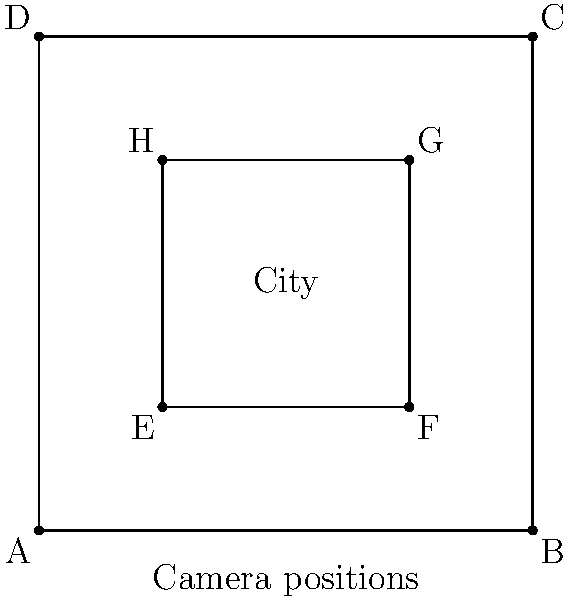As an indie filmmaker, you're planning to capture a cityscape for your documentary on urban life and art. The city can be represented as a rectangle ABCD, and you have four potential camera positions at points E, F, G, and H forming a smaller rectangle inside ABCD. To optimize your shots, you need to determine the maximum number of cameras you can place such that no two cameras can see each other directly (i.e., their line of sight is not obstructed by buildings). How many cameras can you place? To solve this problem, we can use the concept of independent sets in graph theory, applied to the visibility graph of the camera positions. Here's a step-by-step approach:

1. Analyze the visibility between camera positions:
   - E can see F and H directly
   - F can see E and G directly
   - G can see F and H directly
   - H can see E and G directly

2. Create a visibility graph:
   - Each camera position is a node
   - Connect nodes with an edge if they can see each other

3. The resulting graph is a cycle with 4 nodes (E-F-G-H-E)

4. In a cycle graph with 4 nodes, the maximum independent set (set of nodes where no two are adjacent) has 2 nodes

5. This means we can place cameras at 2 positions where they cannot see each other

6. The optimal placements are either:
   - E and G, or
   - F and H

Therefore, the maximum number of cameras that can be placed such that no two cameras can see each other directly is 2.
Answer: 2 cameras 